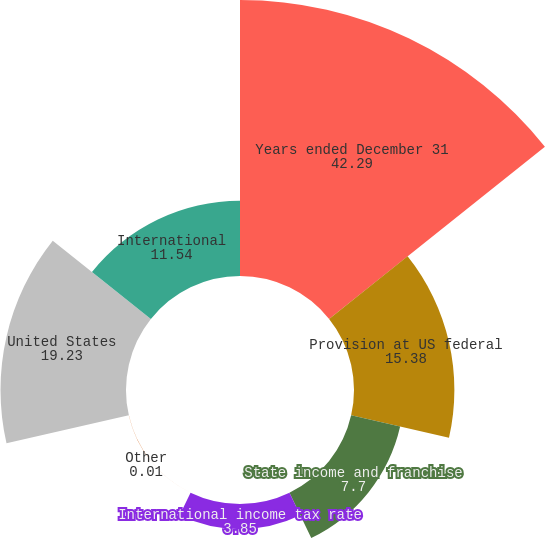<chart> <loc_0><loc_0><loc_500><loc_500><pie_chart><fcel>Years ended December 31<fcel>Provision at US federal<fcel>State income and franchise<fcel>International income tax rate<fcel>Other<fcel>United States<fcel>International<nl><fcel>42.29%<fcel>15.38%<fcel>7.7%<fcel>3.85%<fcel>0.01%<fcel>19.23%<fcel>11.54%<nl></chart> 